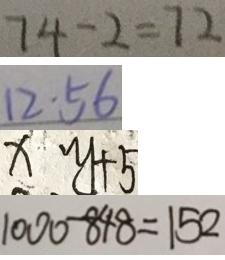Convert formula to latex. <formula><loc_0><loc_0><loc_500><loc_500>7 4 - 2 = 7 2 
 1 2 \cdot 5 6 
 x y + 5 
 1 0 0 0 - 8 4 8 = 1 5 2</formula> 